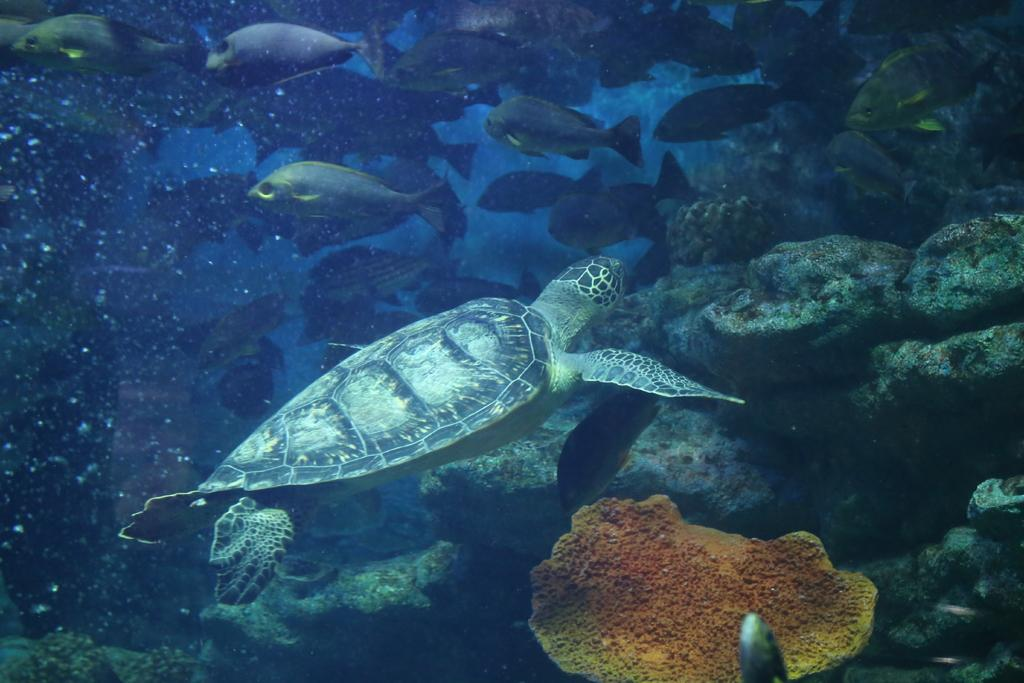What type of animals can be seen in the image? There are fishes and a turtle in the image. What is the setting of the image? The image depicts an underwater environment. What can be seen on the right side of the image? There are stones on the right side of the image. What color is the crayon used to draw the trail in the image? There is no crayon or trail present in the image; it depicts an underwater environment with fishes and a turtle. 